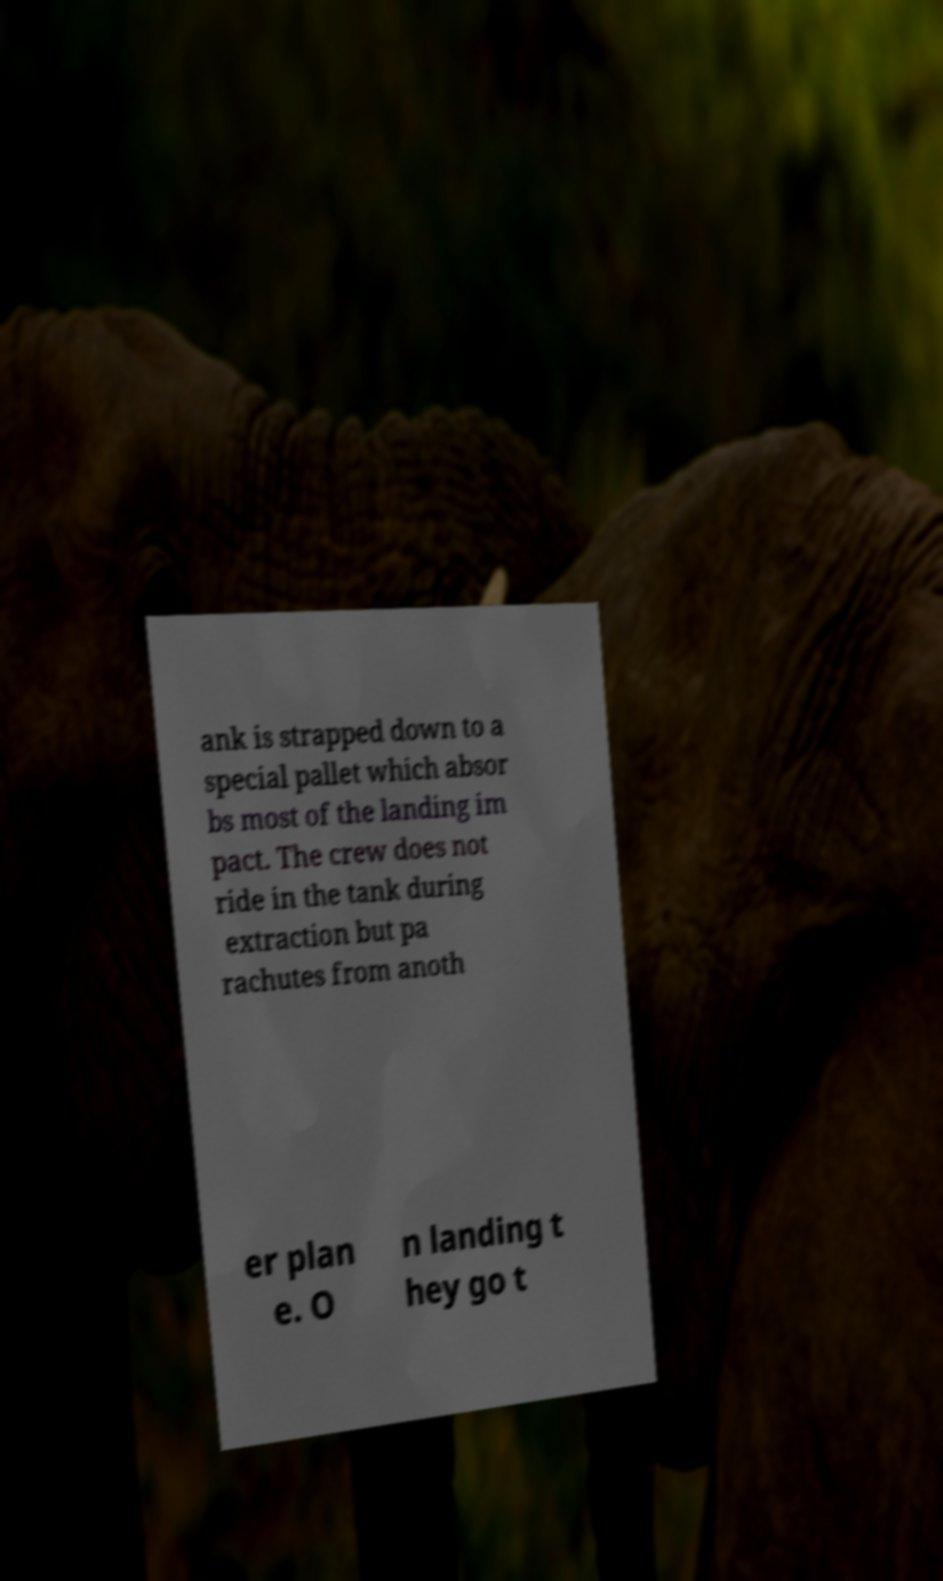Could you assist in decoding the text presented in this image and type it out clearly? ank is strapped down to a special pallet which absor bs most of the landing im pact. The crew does not ride in the tank during extraction but pa rachutes from anoth er plan e. O n landing t hey go t 